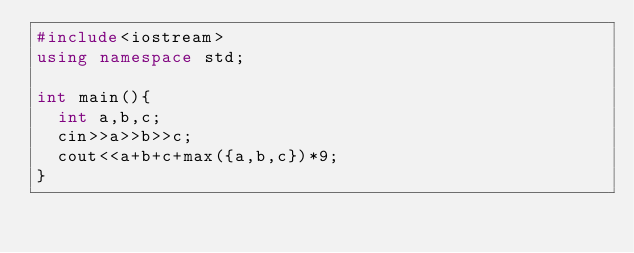<code> <loc_0><loc_0><loc_500><loc_500><_C++_>#include<iostream>
using namespace std;

int main(){
  int a,b,c;
  cin>>a>>b>>c;
  cout<<a+b+c+max({a,b,c})*9;
}</code> 